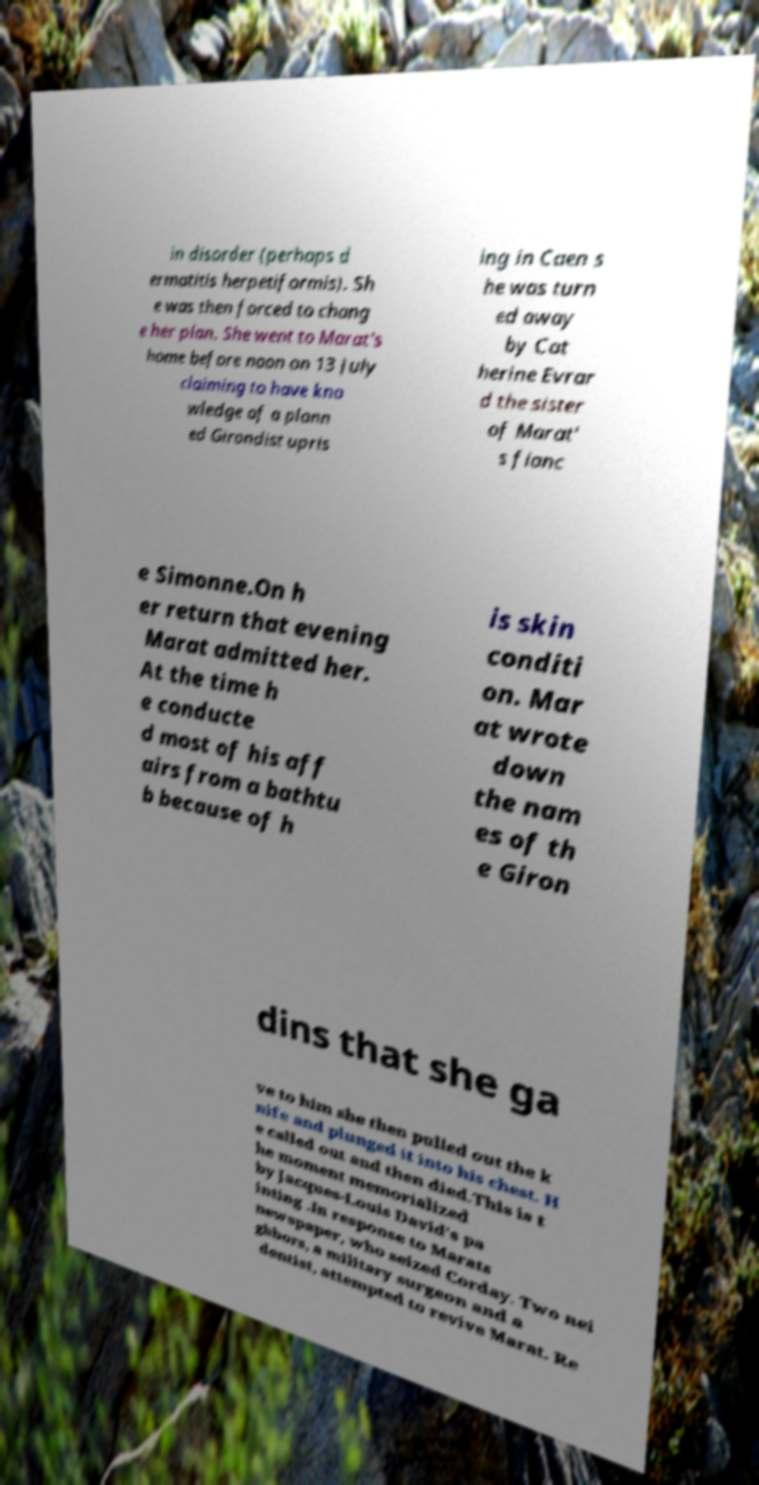Please identify and transcribe the text found in this image. in disorder (perhaps d ermatitis herpetiformis). Sh e was then forced to chang e her plan. She went to Marat's home before noon on 13 July claiming to have kno wledge of a plann ed Girondist upris ing in Caen s he was turn ed away by Cat herine Evrar d the sister of Marat' s fianc e Simonne.On h er return that evening Marat admitted her. At the time h e conducte d most of his aff airs from a bathtu b because of h is skin conditi on. Mar at wrote down the nam es of th e Giron dins that she ga ve to him she then pulled out the k nife and plunged it into his chest. H e called out and then died.This is t he moment memorialized by Jacques-Louis David's pa inting .In response to Marats newspaper, who seized Corday. Two nei ghbors, a military surgeon and a dentist, attempted to revive Marat. Re 